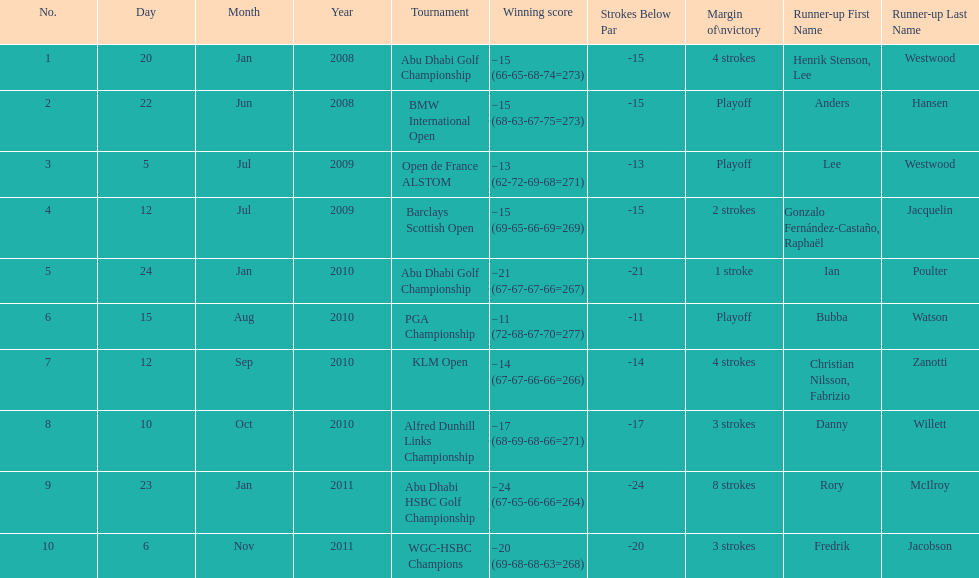How many winning scores were less than -14? 2. 